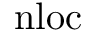Convert formula to latex. <formula><loc_0><loc_0><loc_500><loc_500>n l o c</formula> 